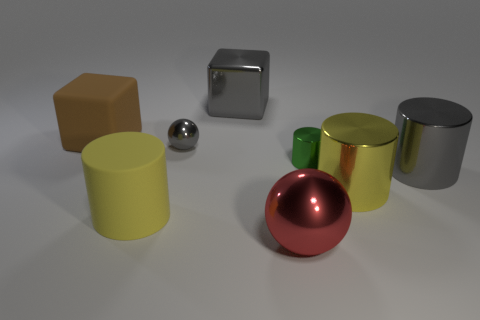Is the color of the metal cube the same as the tiny sphere?
Your answer should be compact. Yes. What shape is the big rubber object that is in front of the big cube that is to the left of the large gray metal block?
Offer a terse response. Cylinder. What number of gray balls are the same size as the red object?
Your answer should be very brief. 0. Are there any large brown metal spheres?
Keep it short and to the point. No. Is there anything else that is the same color as the tiny metallic cylinder?
Make the answer very short. No. What shape is the big red object that is made of the same material as the large gray cylinder?
Offer a terse response. Sphere. There is a metallic cylinder to the left of the yellow thing that is to the right of the gray metal thing that is behind the small ball; what is its color?
Your answer should be very brief. Green. Is the number of tiny gray balls behind the brown cube the same as the number of metallic cubes?
Your response must be concise. No. Is there anything else that has the same material as the large sphere?
Your response must be concise. Yes. There is a small cylinder; is its color the same as the cube that is on the left side of the large yellow matte cylinder?
Your answer should be very brief. No. 